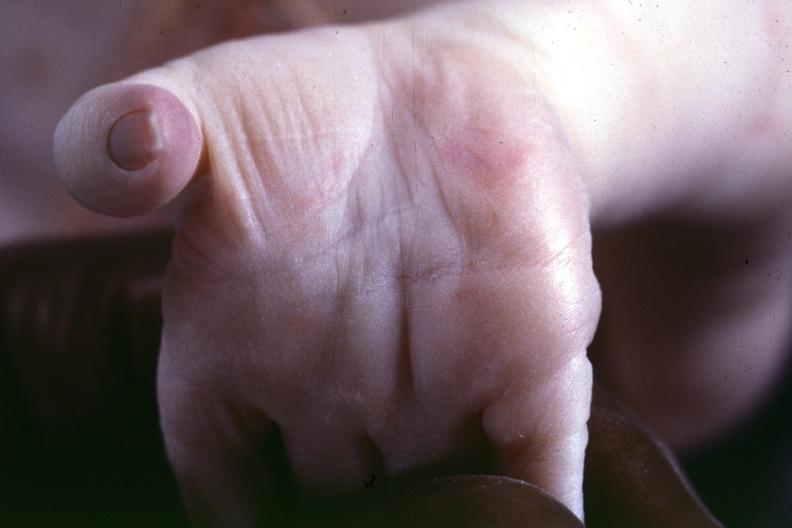was atrophy taken from another case to illustrate the difference?
Answer the question using a single word or phrase. No 